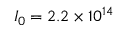Convert formula to latex. <formula><loc_0><loc_0><loc_500><loc_500>I _ { 0 } = 2 . 2 \times 1 0 ^ { 1 4 }</formula> 